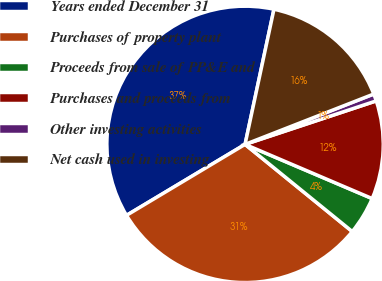Convert chart. <chart><loc_0><loc_0><loc_500><loc_500><pie_chart><fcel>Years ended December 31<fcel>Purchases of property plant<fcel>Proceeds from sale of PP&E and<fcel>Purchases and proceeds from<fcel>Other investing activities<fcel>Net cash used in investing<nl><fcel>36.94%<fcel>30.55%<fcel>4.45%<fcel>11.51%<fcel>0.84%<fcel>15.71%<nl></chart> 